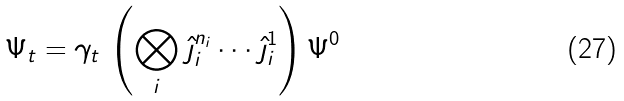Convert formula to latex. <formula><loc_0><loc_0><loc_500><loc_500>\Psi _ { t } = \gamma _ { t } \, \left ( \bigotimes _ { i } \hat { \jmath } _ { i } ^ { n _ { i } } \cdots \hat { \jmath } _ { i } ^ { 1 } \right ) \Psi ^ { 0 }</formula> 